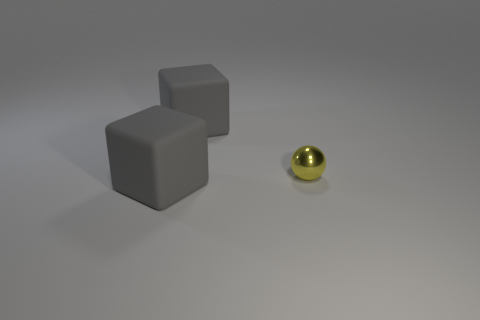Add 2 gray rubber things. How many objects exist? 5 Subtract all blocks. How many objects are left? 1 Subtract 1 balls. How many balls are left? 0 Subtract all green balls. Subtract all cyan blocks. How many balls are left? 1 Subtract all tiny yellow balls. Subtract all tiny yellow metal balls. How many objects are left? 1 Add 2 yellow metal spheres. How many yellow metal spheres are left? 3 Add 3 big purple metallic balls. How many big purple metallic balls exist? 3 Subtract 1 yellow balls. How many objects are left? 2 